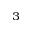Convert formula to latex. <formula><loc_0><loc_0><loc_500><loc_500>^ { 3 }</formula> 